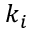<formula> <loc_0><loc_0><loc_500><loc_500>k _ { i }</formula> 